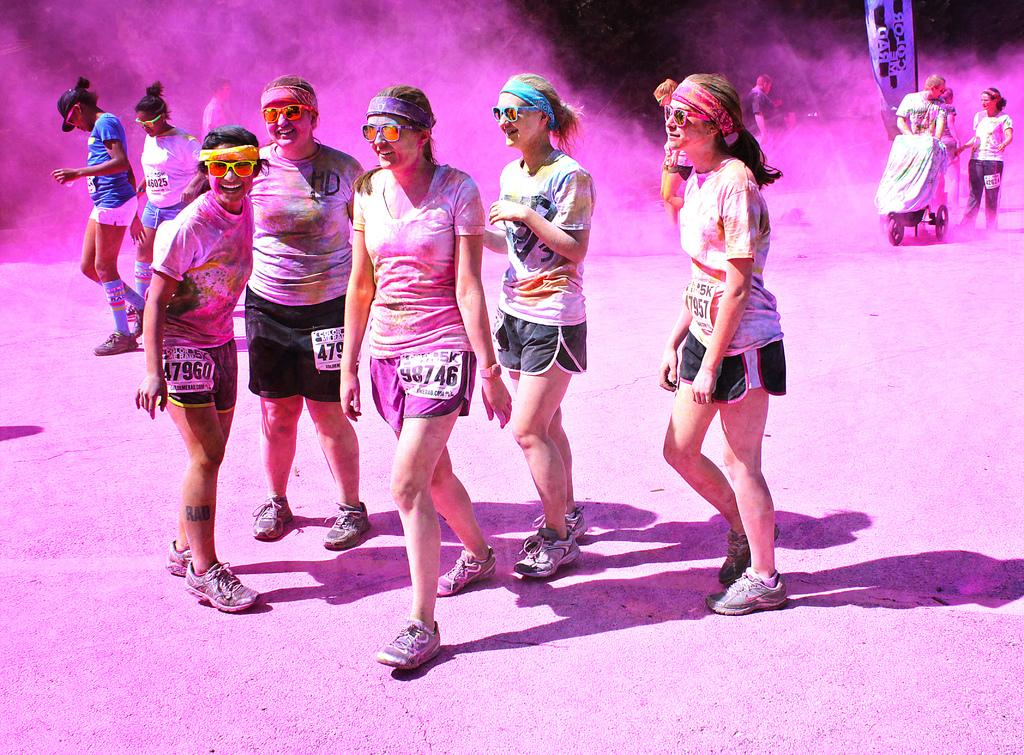What are the people in the image doing? The persons in the image are standing on the ground. Can you describe any objects in the image that are covered? Yes, there is an object covered with cloth in the image. What type of music can be heard playing in the background of the image? There is no music or sound present in the image, as it is a still photograph. 